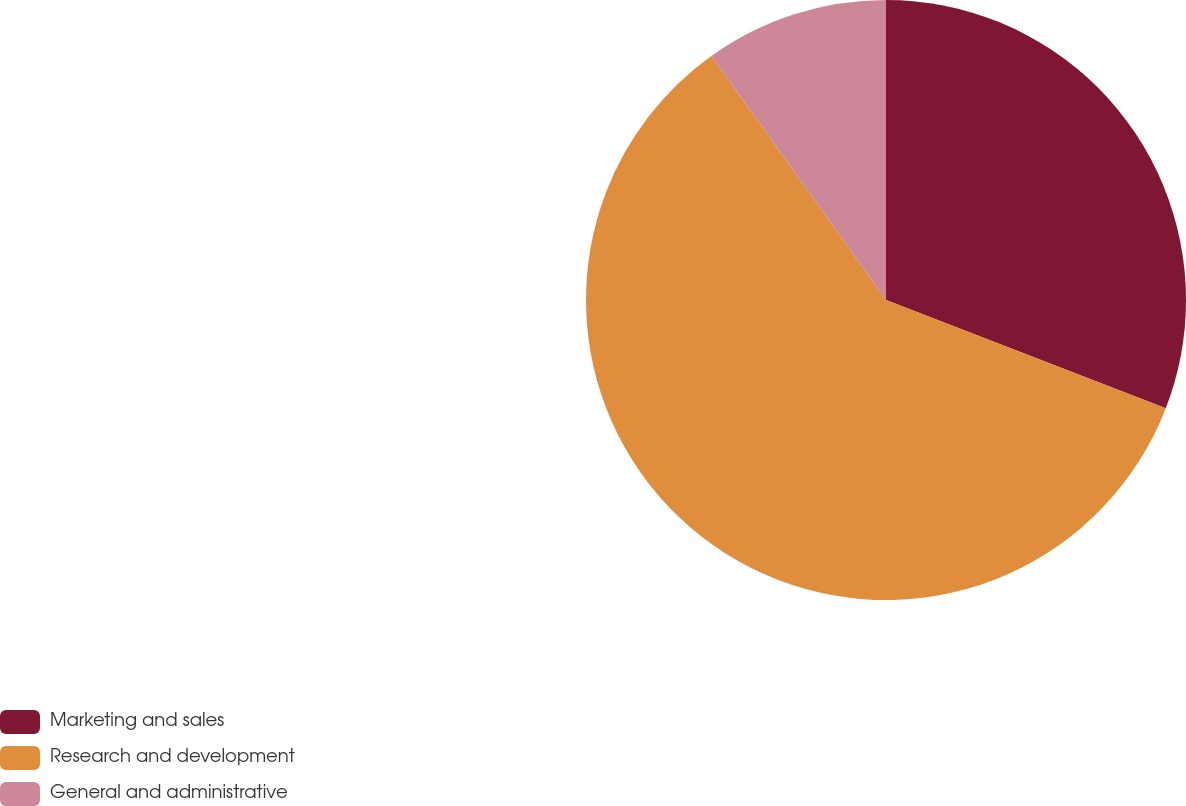Convert chart to OTSL. <chart><loc_0><loc_0><loc_500><loc_500><pie_chart><fcel>Marketing and sales<fcel>Research and development<fcel>General and administrative<nl><fcel>30.88%<fcel>59.24%<fcel>9.89%<nl></chart> 